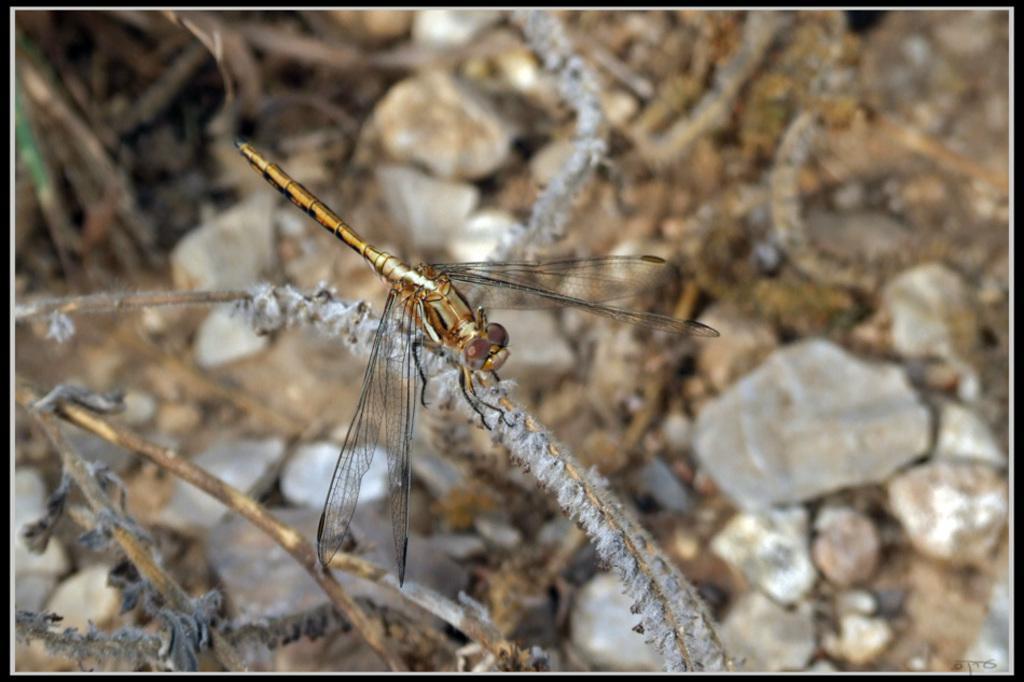Describe this image in one or two sentences. In this image we can see dragonfly on stem and we can see stems. In the background of the image it is blurry and we can see stones. 